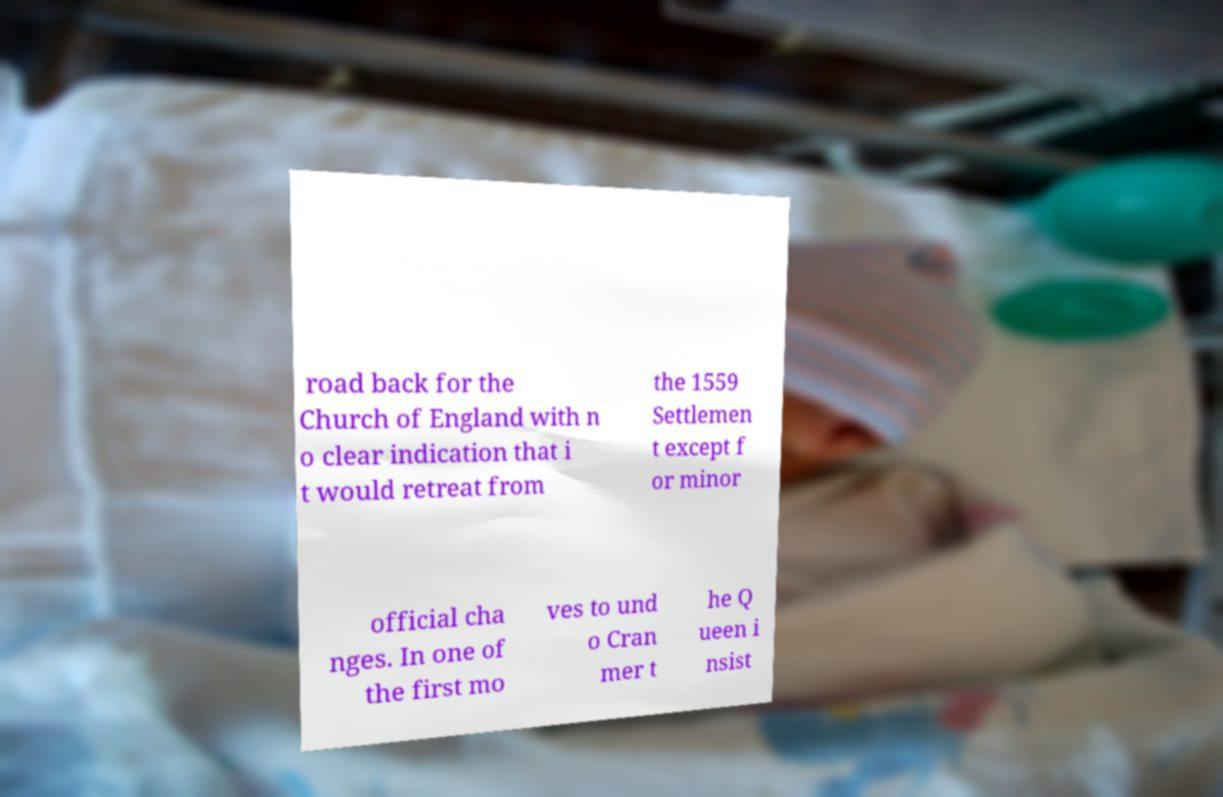Could you assist in decoding the text presented in this image and type it out clearly? road back for the Church of England with n o clear indication that i t would retreat from the 1559 Settlemen t except f or minor official cha nges. In one of the first mo ves to und o Cran mer t he Q ueen i nsist 